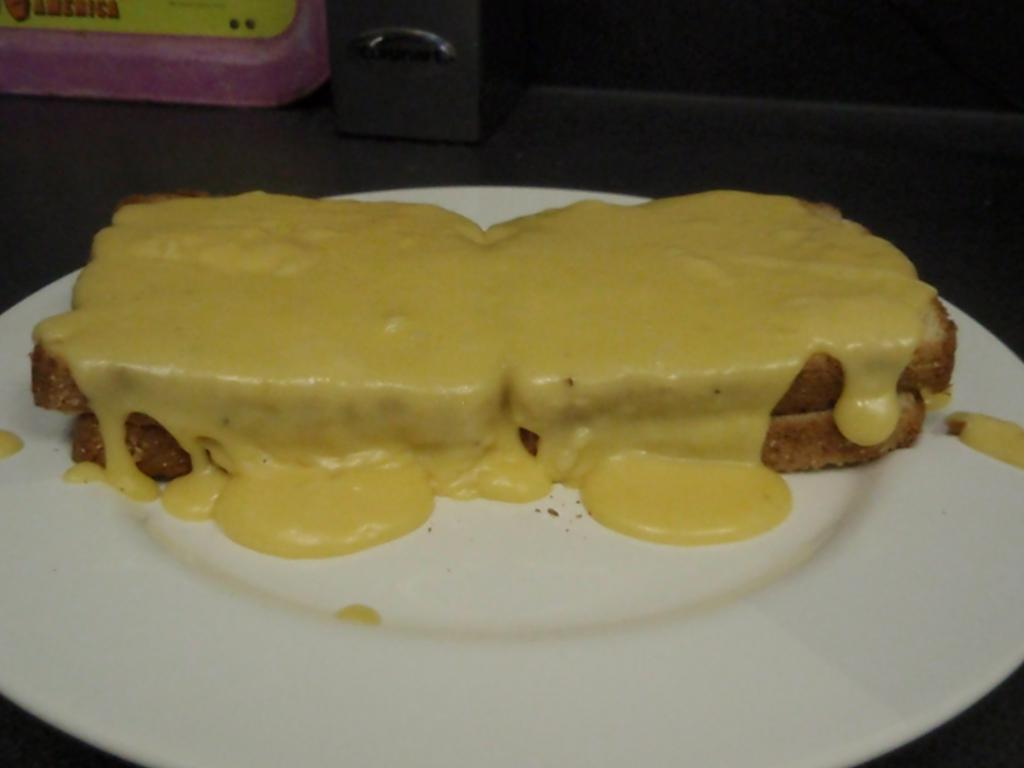What is placed on the plate in the image? There is an edible placed on a plate in the image. Can you describe any other objects visible in the image? There are other objects visible in the background of the image, but their specific details are not provided. What type of bun is being used to fight in the image? There is no bun or fighting depicted in the image; it only shows an edible placed on a plate and other objects in the background. 